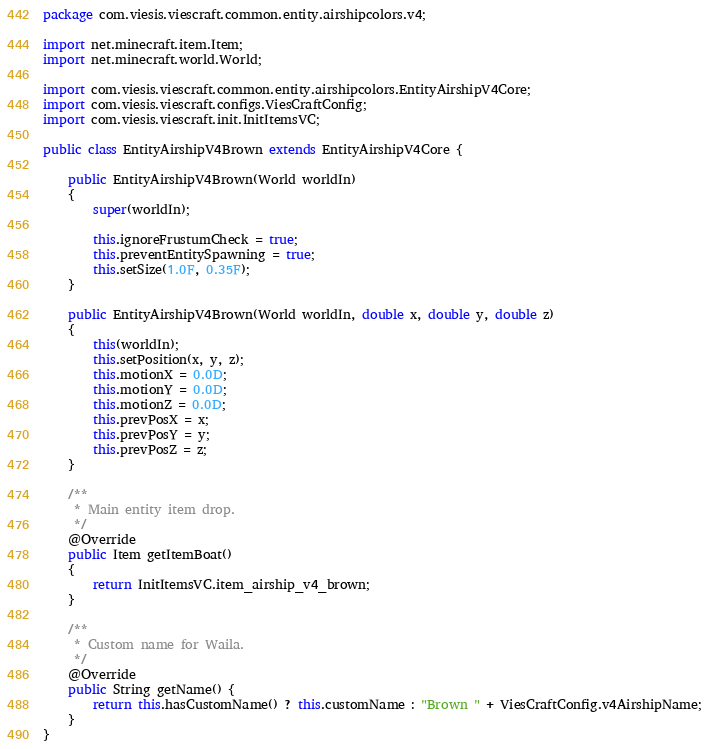<code> <loc_0><loc_0><loc_500><loc_500><_Java_>package com.viesis.viescraft.common.entity.airshipcolors.v4;

import net.minecraft.item.Item;
import net.minecraft.world.World;

import com.viesis.viescraft.common.entity.airshipcolors.EntityAirshipV4Core;
import com.viesis.viescraft.configs.ViesCraftConfig;
import com.viesis.viescraft.init.InitItemsVC;

public class EntityAirshipV4Brown extends EntityAirshipV4Core {
	
	public EntityAirshipV4Brown(World worldIn)
    {
        super(worldIn);
        
        this.ignoreFrustumCheck = true;
        this.preventEntitySpawning = true;
        this.setSize(1.0F, 0.35F);
    }
	
    public EntityAirshipV4Brown(World worldIn, double x, double y, double z)
    {
        this(worldIn);
        this.setPosition(x, y, z);
        this.motionX = 0.0D;
        this.motionY = 0.0D;
        this.motionZ = 0.0D;
        this.prevPosX = x;
        this.prevPosY = y;
        this.prevPosZ = z;
    }
    
	/**
     * Main entity item drop.
     */
    @Override
	public Item getItemBoat()
    {
		return InitItemsVC.item_airship_v4_brown;
    }
    
    /**
     * Custom name for Waila.
     */
	@Override
	public String getName() {
		return this.hasCustomName() ? this.customName : "Brown " + ViesCraftConfig.v4AirshipName;
	}
}
</code> 